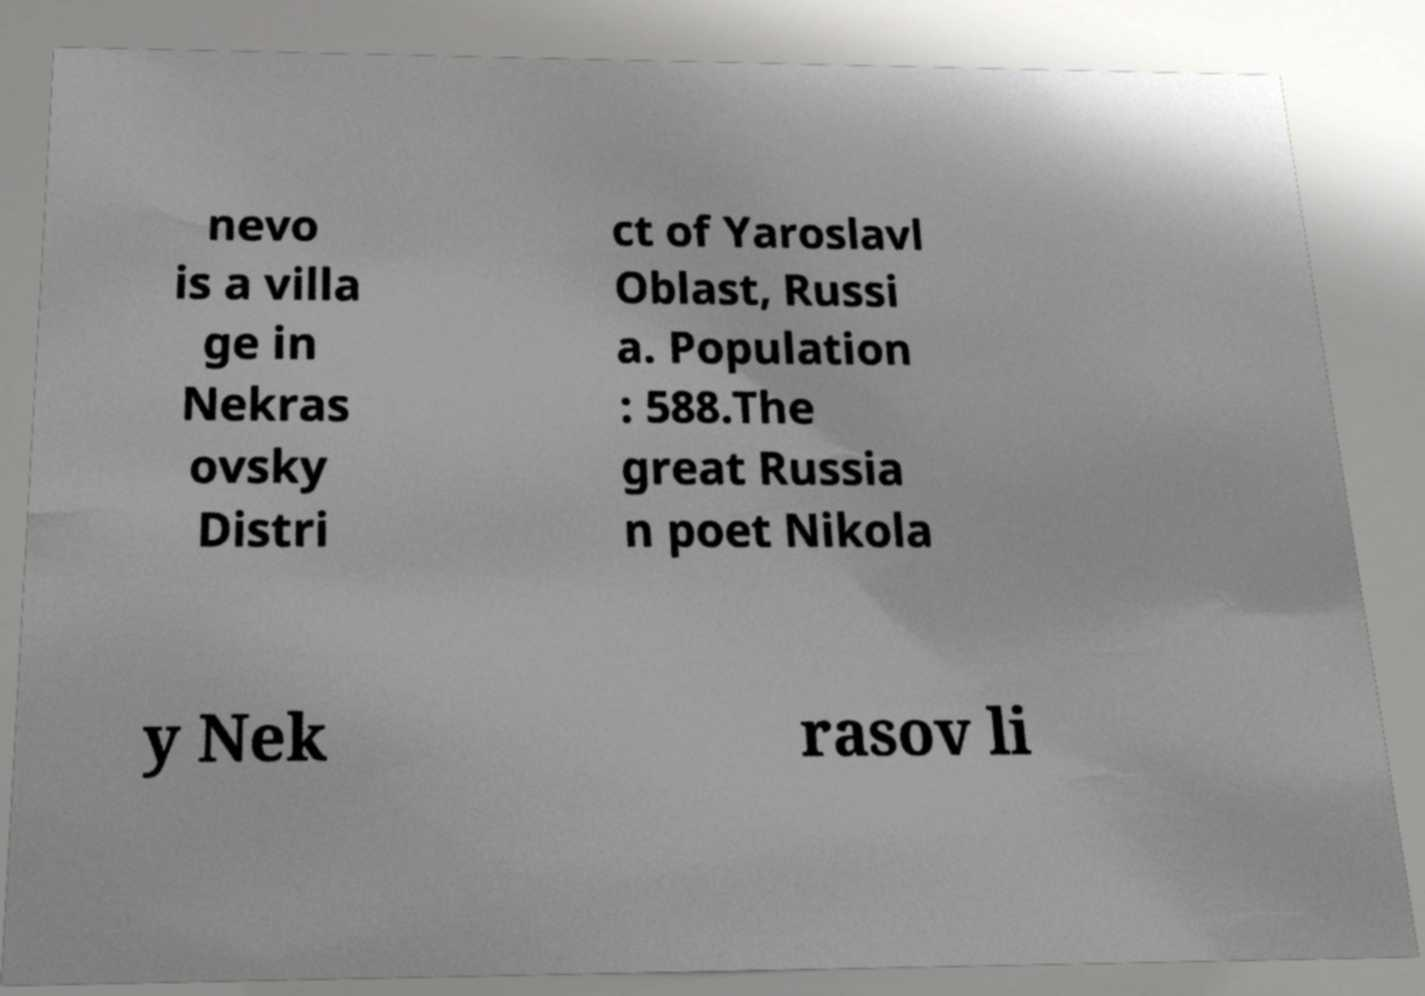Could you assist in decoding the text presented in this image and type it out clearly? nevo is a villa ge in Nekras ovsky Distri ct of Yaroslavl Oblast, Russi a. Population : 588.The great Russia n poet Nikola y Nek rasov li 